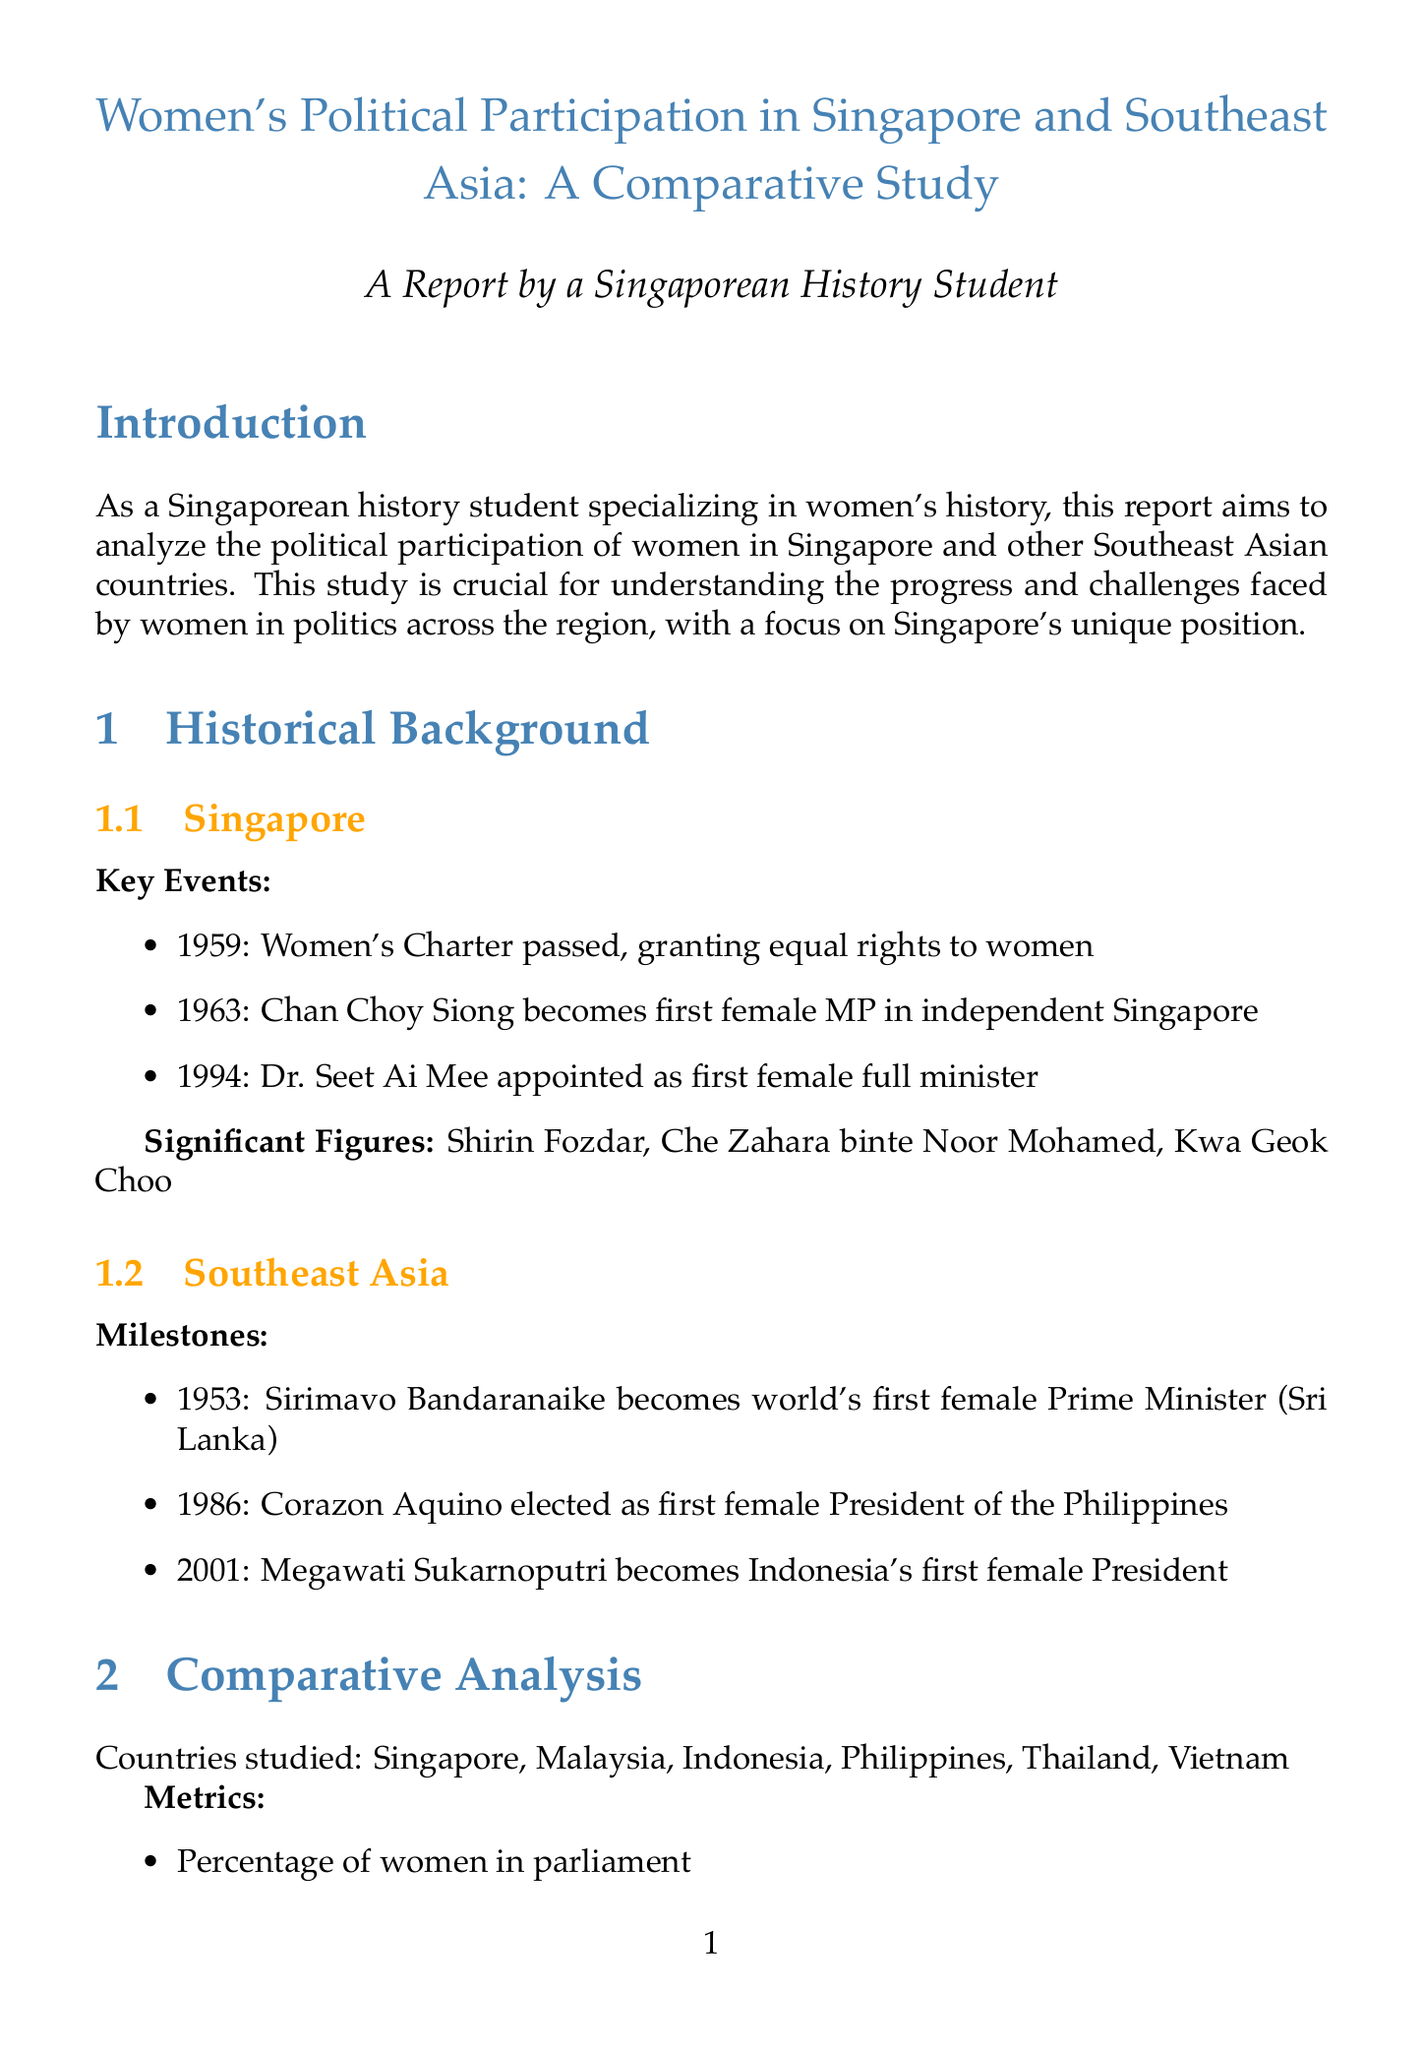what is the title of the report? The title of the report is specified in the document as "Women's Political Participation in Singapore and Southeast Asia: A Comparative Study."
Answer: Women's Political Participation in Singapore and Southeast Asia: A Comparative Study who was the first female MP in Singapore? The document mentions Chan Choy Siong as the first female MP in independent Singapore in 1963.
Answer: Chan Choy Siong which year did Singapore pass the Women's Charter? The document states that the Women's Charter was passed in 1959.
Answer: 1959 what is one of the recommendations for promoting women's political participation? The report includes implementing gender quotas in political parties as a recommendation.
Answer: Implement gender quotas in political parties who conducted interviews with female politicians? The report indicates that interviews were conducted with prominent female politicians, including Halimah Yacob.
Answer: Halimah Yacob what cultural challenge do women face in politics according to the report? The document lists cultural stereotypes and traditional gender roles as a challenge faced by women in politics.
Answer: Cultural stereotypes and traditional gender roles what position did Grace Fu hold in Singapore? The report identifies Grace Fu as the Minister for Sustainability and the Environment.
Answer: Minister for Sustainability and the Environment how many countries were analyzed in the comparative study? The document states that a total of six countries were analyzed: Singapore, Malaysia, Indonesia, Philippines, Thailand, and Vietnam.
Answer: Six countries what was one milestone for women's political participation in Southeast Asia? The document mentions Sirimavo Bandaranaike becoming the world's first female Prime Minister in 1953 as a significant milestone.
Answer: Sirimavo Bandaranaike becomes the world's first female Prime Minister in 1953 